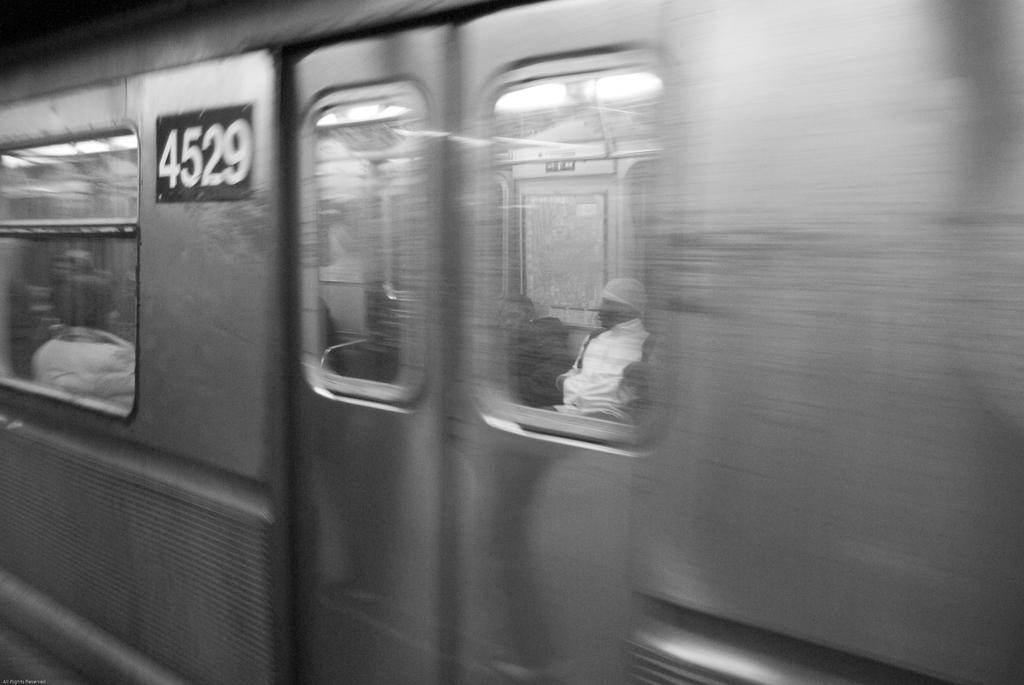What is the number?
Provide a short and direct response. 4529. 